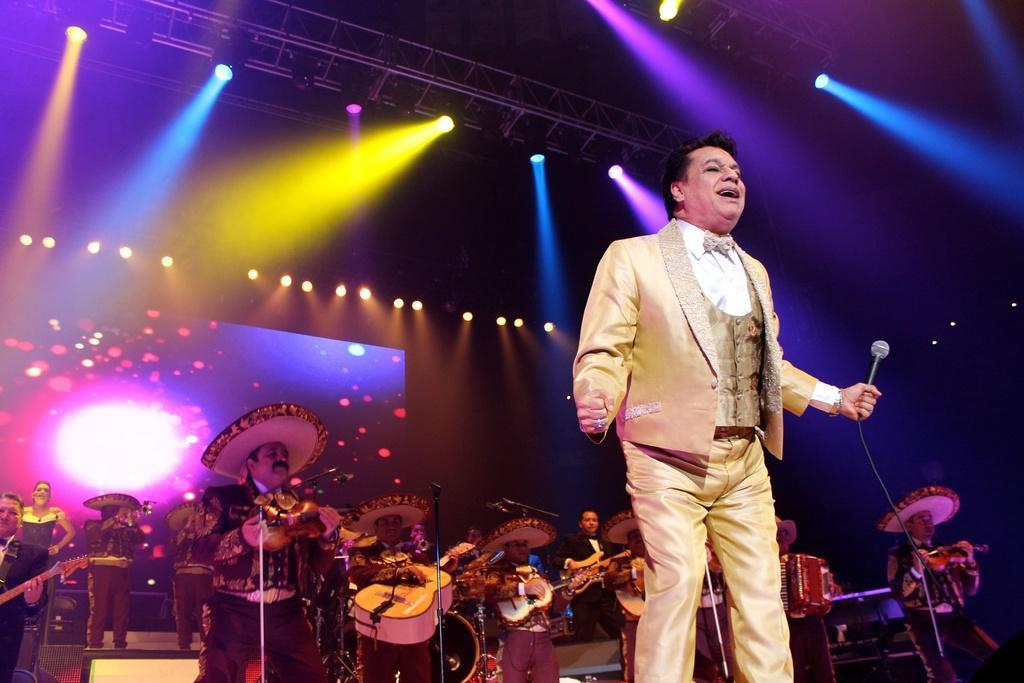Please provide a concise description of this image. In this picture on the right side, we can see a man wearing a cream color suit and he is also holding microphone on one hand. In the background, we can see group of people standing and playing their musical instruments in front of a microphone, we can also see a screen. On the top, we can see a roof with few lights. 